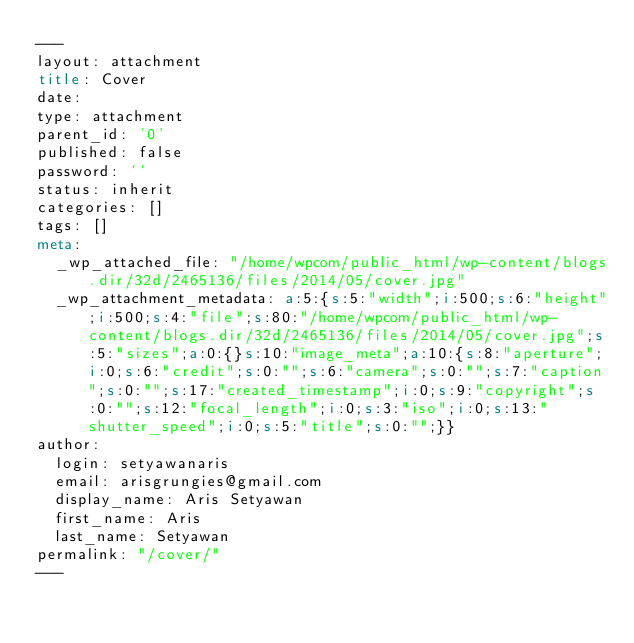<code> <loc_0><loc_0><loc_500><loc_500><_HTML_>---
layout: attachment
title: Cover
date: 
type: attachment
parent_id: '0'
published: false
password: ''
status: inherit
categories: []
tags: []
meta:
  _wp_attached_file: "/home/wpcom/public_html/wp-content/blogs.dir/32d/2465136/files/2014/05/cover.jpg"
  _wp_attachment_metadata: a:5:{s:5:"width";i:500;s:6:"height";i:500;s:4:"file";s:80:"/home/wpcom/public_html/wp-content/blogs.dir/32d/2465136/files/2014/05/cover.jpg";s:5:"sizes";a:0:{}s:10:"image_meta";a:10:{s:8:"aperture";i:0;s:6:"credit";s:0:"";s:6:"camera";s:0:"";s:7:"caption";s:0:"";s:17:"created_timestamp";i:0;s:9:"copyright";s:0:"";s:12:"focal_length";i:0;s:3:"iso";i:0;s:13:"shutter_speed";i:0;s:5:"title";s:0:"";}}
author:
  login: setyawanaris
  email: arisgrungies@gmail.com
  display_name: Aris Setyawan
  first_name: Aris
  last_name: Setyawan
permalink: "/cover/"
---

</code> 